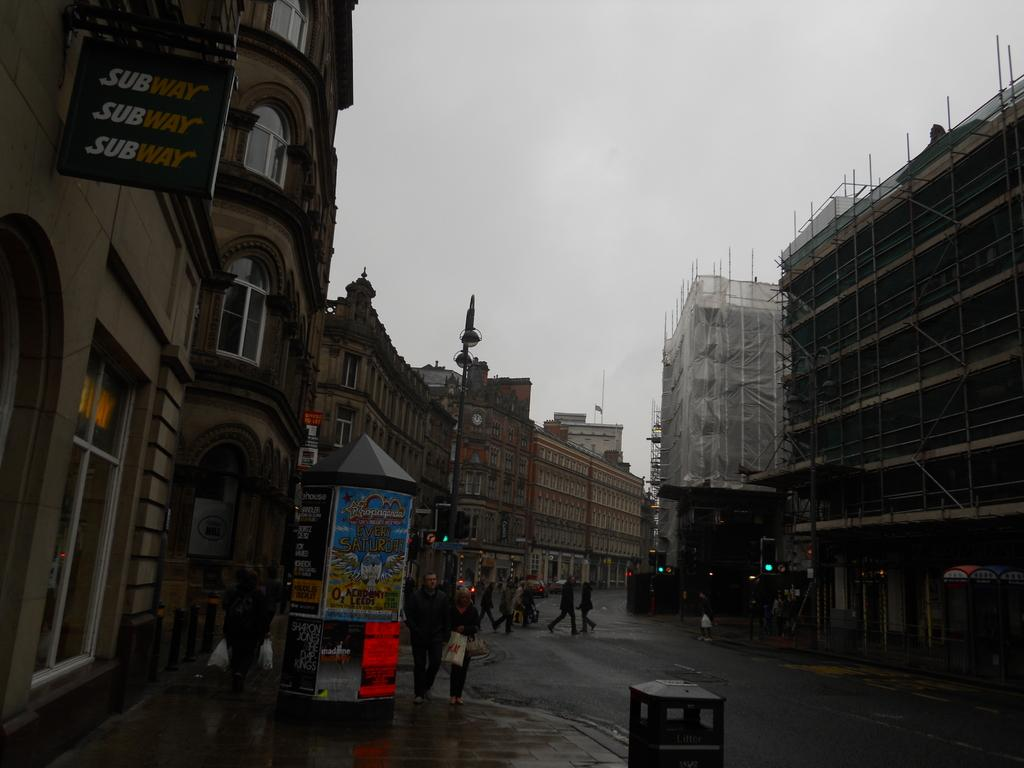What is the main subject in the center of the image? There are buildings in the center of the image. Are there any people visible in the image? Yes, there are persons in the image. How would you describe the weather based on the sky in the image? The sky is cloudy in the image. What health benefits can be seen in the image? There are no health benefits visible in the image. 